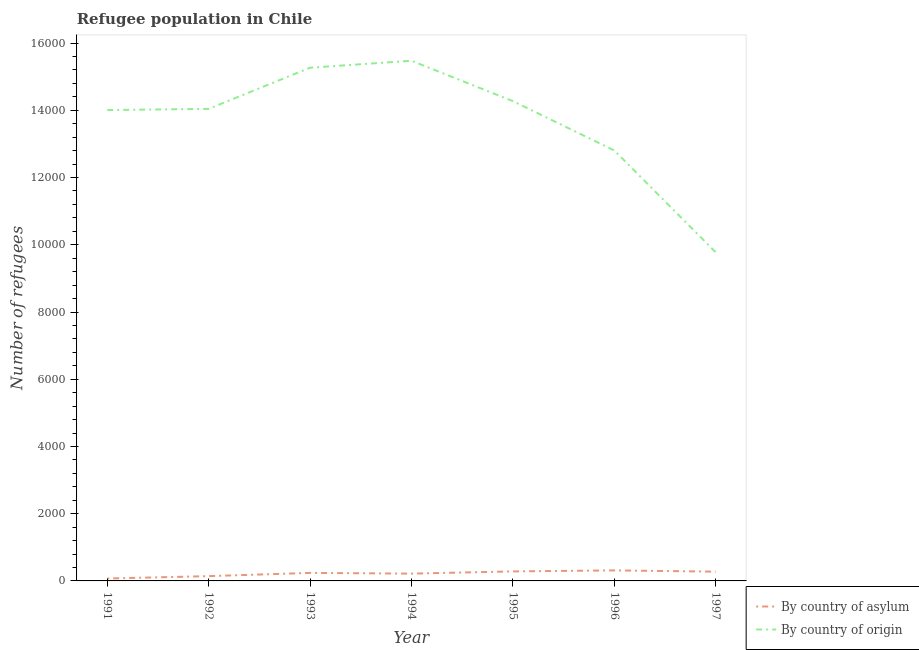What is the number of refugees by country of asylum in 1994?
Provide a succinct answer. 217. Across all years, what is the maximum number of refugees by country of origin?
Your answer should be compact. 1.55e+04. Across all years, what is the minimum number of refugees by country of asylum?
Provide a succinct answer. 72. In which year was the number of refugees by country of asylum maximum?
Your answer should be very brief. 1996. What is the total number of refugees by country of origin in the graph?
Make the answer very short. 9.56e+04. What is the difference between the number of refugees by country of asylum in 1992 and that in 1997?
Your answer should be compact. -134. What is the difference between the number of refugees by country of asylum in 1997 and the number of refugees by country of origin in 1995?
Give a very brief answer. -1.40e+04. What is the average number of refugees by country of asylum per year?
Your answer should be compact. 220.29. In the year 1994, what is the difference between the number of refugees by country of asylum and number of refugees by country of origin?
Provide a succinct answer. -1.53e+04. In how many years, is the number of refugees by country of asylum greater than 11600?
Ensure brevity in your answer.  0. What is the ratio of the number of refugees by country of origin in 1991 to that in 1996?
Provide a short and direct response. 1.09. Is the number of refugees by country of asylum in 1991 less than that in 1993?
Your answer should be very brief. Yes. What is the difference between the highest and the second highest number of refugees by country of origin?
Offer a very short reply. 207. What is the difference between the highest and the lowest number of refugees by country of origin?
Make the answer very short. 5698. Does the number of refugees by country of asylum monotonically increase over the years?
Give a very brief answer. No. How many lines are there?
Keep it short and to the point. 2. How many years are there in the graph?
Keep it short and to the point. 7. What is the difference between two consecutive major ticks on the Y-axis?
Your answer should be compact. 2000. Are the values on the major ticks of Y-axis written in scientific E-notation?
Provide a succinct answer. No. How are the legend labels stacked?
Your answer should be very brief. Vertical. What is the title of the graph?
Offer a terse response. Refugee population in Chile. What is the label or title of the Y-axis?
Ensure brevity in your answer.  Number of refugees. What is the Number of refugees of By country of origin in 1991?
Keep it short and to the point. 1.40e+04. What is the Number of refugees of By country of asylum in 1992?
Offer a very short reply. 142. What is the Number of refugees of By country of origin in 1992?
Keep it short and to the point. 1.40e+04. What is the Number of refugees of By country of asylum in 1993?
Keep it short and to the point. 239. What is the Number of refugees in By country of origin in 1993?
Provide a short and direct response. 1.53e+04. What is the Number of refugees of By country of asylum in 1994?
Ensure brevity in your answer.  217. What is the Number of refugees in By country of origin in 1994?
Your answer should be compact. 1.55e+04. What is the Number of refugees in By country of asylum in 1995?
Keep it short and to the point. 283. What is the Number of refugees in By country of origin in 1995?
Provide a succinct answer. 1.43e+04. What is the Number of refugees in By country of asylum in 1996?
Your answer should be compact. 313. What is the Number of refugees of By country of origin in 1996?
Your response must be concise. 1.28e+04. What is the Number of refugees of By country of asylum in 1997?
Keep it short and to the point. 276. What is the Number of refugees in By country of origin in 1997?
Provide a succinct answer. 9776. Across all years, what is the maximum Number of refugees in By country of asylum?
Offer a terse response. 313. Across all years, what is the maximum Number of refugees of By country of origin?
Your response must be concise. 1.55e+04. Across all years, what is the minimum Number of refugees in By country of asylum?
Ensure brevity in your answer.  72. Across all years, what is the minimum Number of refugees of By country of origin?
Your response must be concise. 9776. What is the total Number of refugees in By country of asylum in the graph?
Give a very brief answer. 1542. What is the total Number of refugees in By country of origin in the graph?
Provide a succinct answer. 9.56e+04. What is the difference between the Number of refugees in By country of asylum in 1991 and that in 1992?
Keep it short and to the point. -70. What is the difference between the Number of refugees in By country of origin in 1991 and that in 1992?
Make the answer very short. -36. What is the difference between the Number of refugees of By country of asylum in 1991 and that in 1993?
Provide a succinct answer. -167. What is the difference between the Number of refugees in By country of origin in 1991 and that in 1993?
Your answer should be very brief. -1260. What is the difference between the Number of refugees of By country of asylum in 1991 and that in 1994?
Ensure brevity in your answer.  -145. What is the difference between the Number of refugees of By country of origin in 1991 and that in 1994?
Your response must be concise. -1467. What is the difference between the Number of refugees of By country of asylum in 1991 and that in 1995?
Make the answer very short. -211. What is the difference between the Number of refugees of By country of origin in 1991 and that in 1995?
Offer a terse response. -266. What is the difference between the Number of refugees of By country of asylum in 1991 and that in 1996?
Provide a short and direct response. -241. What is the difference between the Number of refugees of By country of origin in 1991 and that in 1996?
Provide a succinct answer. 1202. What is the difference between the Number of refugees in By country of asylum in 1991 and that in 1997?
Make the answer very short. -204. What is the difference between the Number of refugees in By country of origin in 1991 and that in 1997?
Give a very brief answer. 4231. What is the difference between the Number of refugees of By country of asylum in 1992 and that in 1993?
Offer a terse response. -97. What is the difference between the Number of refugees of By country of origin in 1992 and that in 1993?
Provide a short and direct response. -1224. What is the difference between the Number of refugees of By country of asylum in 1992 and that in 1994?
Offer a very short reply. -75. What is the difference between the Number of refugees of By country of origin in 1992 and that in 1994?
Your response must be concise. -1431. What is the difference between the Number of refugees of By country of asylum in 1992 and that in 1995?
Offer a very short reply. -141. What is the difference between the Number of refugees in By country of origin in 1992 and that in 1995?
Keep it short and to the point. -230. What is the difference between the Number of refugees of By country of asylum in 1992 and that in 1996?
Your answer should be compact. -171. What is the difference between the Number of refugees of By country of origin in 1992 and that in 1996?
Your answer should be compact. 1238. What is the difference between the Number of refugees in By country of asylum in 1992 and that in 1997?
Give a very brief answer. -134. What is the difference between the Number of refugees in By country of origin in 1992 and that in 1997?
Provide a short and direct response. 4267. What is the difference between the Number of refugees in By country of origin in 1993 and that in 1994?
Your answer should be very brief. -207. What is the difference between the Number of refugees in By country of asylum in 1993 and that in 1995?
Provide a short and direct response. -44. What is the difference between the Number of refugees of By country of origin in 1993 and that in 1995?
Offer a terse response. 994. What is the difference between the Number of refugees of By country of asylum in 1993 and that in 1996?
Your response must be concise. -74. What is the difference between the Number of refugees of By country of origin in 1993 and that in 1996?
Your answer should be very brief. 2462. What is the difference between the Number of refugees of By country of asylum in 1993 and that in 1997?
Offer a terse response. -37. What is the difference between the Number of refugees of By country of origin in 1993 and that in 1997?
Your response must be concise. 5491. What is the difference between the Number of refugees of By country of asylum in 1994 and that in 1995?
Your response must be concise. -66. What is the difference between the Number of refugees of By country of origin in 1994 and that in 1995?
Offer a terse response. 1201. What is the difference between the Number of refugees in By country of asylum in 1994 and that in 1996?
Ensure brevity in your answer.  -96. What is the difference between the Number of refugees in By country of origin in 1994 and that in 1996?
Ensure brevity in your answer.  2669. What is the difference between the Number of refugees of By country of asylum in 1994 and that in 1997?
Provide a succinct answer. -59. What is the difference between the Number of refugees of By country of origin in 1994 and that in 1997?
Offer a very short reply. 5698. What is the difference between the Number of refugees of By country of asylum in 1995 and that in 1996?
Offer a terse response. -30. What is the difference between the Number of refugees in By country of origin in 1995 and that in 1996?
Ensure brevity in your answer.  1468. What is the difference between the Number of refugees of By country of asylum in 1995 and that in 1997?
Make the answer very short. 7. What is the difference between the Number of refugees in By country of origin in 1995 and that in 1997?
Make the answer very short. 4497. What is the difference between the Number of refugees in By country of asylum in 1996 and that in 1997?
Ensure brevity in your answer.  37. What is the difference between the Number of refugees of By country of origin in 1996 and that in 1997?
Your response must be concise. 3029. What is the difference between the Number of refugees of By country of asylum in 1991 and the Number of refugees of By country of origin in 1992?
Your response must be concise. -1.40e+04. What is the difference between the Number of refugees in By country of asylum in 1991 and the Number of refugees in By country of origin in 1993?
Give a very brief answer. -1.52e+04. What is the difference between the Number of refugees in By country of asylum in 1991 and the Number of refugees in By country of origin in 1994?
Provide a short and direct response. -1.54e+04. What is the difference between the Number of refugees in By country of asylum in 1991 and the Number of refugees in By country of origin in 1995?
Offer a terse response. -1.42e+04. What is the difference between the Number of refugees of By country of asylum in 1991 and the Number of refugees of By country of origin in 1996?
Offer a very short reply. -1.27e+04. What is the difference between the Number of refugees in By country of asylum in 1991 and the Number of refugees in By country of origin in 1997?
Offer a terse response. -9704. What is the difference between the Number of refugees of By country of asylum in 1992 and the Number of refugees of By country of origin in 1993?
Provide a short and direct response. -1.51e+04. What is the difference between the Number of refugees of By country of asylum in 1992 and the Number of refugees of By country of origin in 1994?
Offer a very short reply. -1.53e+04. What is the difference between the Number of refugees of By country of asylum in 1992 and the Number of refugees of By country of origin in 1995?
Provide a short and direct response. -1.41e+04. What is the difference between the Number of refugees of By country of asylum in 1992 and the Number of refugees of By country of origin in 1996?
Provide a succinct answer. -1.27e+04. What is the difference between the Number of refugees of By country of asylum in 1992 and the Number of refugees of By country of origin in 1997?
Your response must be concise. -9634. What is the difference between the Number of refugees in By country of asylum in 1993 and the Number of refugees in By country of origin in 1994?
Make the answer very short. -1.52e+04. What is the difference between the Number of refugees of By country of asylum in 1993 and the Number of refugees of By country of origin in 1995?
Provide a short and direct response. -1.40e+04. What is the difference between the Number of refugees of By country of asylum in 1993 and the Number of refugees of By country of origin in 1996?
Your answer should be very brief. -1.26e+04. What is the difference between the Number of refugees in By country of asylum in 1993 and the Number of refugees in By country of origin in 1997?
Keep it short and to the point. -9537. What is the difference between the Number of refugees of By country of asylum in 1994 and the Number of refugees of By country of origin in 1995?
Make the answer very short. -1.41e+04. What is the difference between the Number of refugees in By country of asylum in 1994 and the Number of refugees in By country of origin in 1996?
Keep it short and to the point. -1.26e+04. What is the difference between the Number of refugees in By country of asylum in 1994 and the Number of refugees in By country of origin in 1997?
Offer a very short reply. -9559. What is the difference between the Number of refugees in By country of asylum in 1995 and the Number of refugees in By country of origin in 1996?
Ensure brevity in your answer.  -1.25e+04. What is the difference between the Number of refugees in By country of asylum in 1995 and the Number of refugees in By country of origin in 1997?
Your answer should be compact. -9493. What is the difference between the Number of refugees in By country of asylum in 1996 and the Number of refugees in By country of origin in 1997?
Make the answer very short. -9463. What is the average Number of refugees in By country of asylum per year?
Make the answer very short. 220.29. What is the average Number of refugees in By country of origin per year?
Offer a very short reply. 1.37e+04. In the year 1991, what is the difference between the Number of refugees of By country of asylum and Number of refugees of By country of origin?
Give a very brief answer. -1.39e+04. In the year 1992, what is the difference between the Number of refugees in By country of asylum and Number of refugees in By country of origin?
Provide a succinct answer. -1.39e+04. In the year 1993, what is the difference between the Number of refugees of By country of asylum and Number of refugees of By country of origin?
Ensure brevity in your answer.  -1.50e+04. In the year 1994, what is the difference between the Number of refugees of By country of asylum and Number of refugees of By country of origin?
Offer a terse response. -1.53e+04. In the year 1995, what is the difference between the Number of refugees of By country of asylum and Number of refugees of By country of origin?
Ensure brevity in your answer.  -1.40e+04. In the year 1996, what is the difference between the Number of refugees of By country of asylum and Number of refugees of By country of origin?
Offer a very short reply. -1.25e+04. In the year 1997, what is the difference between the Number of refugees of By country of asylum and Number of refugees of By country of origin?
Give a very brief answer. -9500. What is the ratio of the Number of refugees of By country of asylum in 1991 to that in 1992?
Keep it short and to the point. 0.51. What is the ratio of the Number of refugees of By country of asylum in 1991 to that in 1993?
Keep it short and to the point. 0.3. What is the ratio of the Number of refugees of By country of origin in 1991 to that in 1993?
Offer a terse response. 0.92. What is the ratio of the Number of refugees in By country of asylum in 1991 to that in 1994?
Make the answer very short. 0.33. What is the ratio of the Number of refugees of By country of origin in 1991 to that in 1994?
Ensure brevity in your answer.  0.91. What is the ratio of the Number of refugees of By country of asylum in 1991 to that in 1995?
Offer a terse response. 0.25. What is the ratio of the Number of refugees in By country of origin in 1991 to that in 1995?
Ensure brevity in your answer.  0.98. What is the ratio of the Number of refugees of By country of asylum in 1991 to that in 1996?
Your response must be concise. 0.23. What is the ratio of the Number of refugees in By country of origin in 1991 to that in 1996?
Your answer should be compact. 1.09. What is the ratio of the Number of refugees in By country of asylum in 1991 to that in 1997?
Offer a terse response. 0.26. What is the ratio of the Number of refugees of By country of origin in 1991 to that in 1997?
Keep it short and to the point. 1.43. What is the ratio of the Number of refugees in By country of asylum in 1992 to that in 1993?
Keep it short and to the point. 0.59. What is the ratio of the Number of refugees of By country of origin in 1992 to that in 1993?
Your answer should be compact. 0.92. What is the ratio of the Number of refugees in By country of asylum in 1992 to that in 1994?
Your response must be concise. 0.65. What is the ratio of the Number of refugees in By country of origin in 1992 to that in 1994?
Your response must be concise. 0.91. What is the ratio of the Number of refugees of By country of asylum in 1992 to that in 1995?
Provide a succinct answer. 0.5. What is the ratio of the Number of refugees of By country of origin in 1992 to that in 1995?
Make the answer very short. 0.98. What is the ratio of the Number of refugees in By country of asylum in 1992 to that in 1996?
Keep it short and to the point. 0.45. What is the ratio of the Number of refugees in By country of origin in 1992 to that in 1996?
Give a very brief answer. 1.1. What is the ratio of the Number of refugees of By country of asylum in 1992 to that in 1997?
Give a very brief answer. 0.51. What is the ratio of the Number of refugees of By country of origin in 1992 to that in 1997?
Offer a terse response. 1.44. What is the ratio of the Number of refugees of By country of asylum in 1993 to that in 1994?
Provide a succinct answer. 1.1. What is the ratio of the Number of refugees of By country of origin in 1993 to that in 1994?
Provide a succinct answer. 0.99. What is the ratio of the Number of refugees of By country of asylum in 1993 to that in 1995?
Your answer should be very brief. 0.84. What is the ratio of the Number of refugees in By country of origin in 1993 to that in 1995?
Ensure brevity in your answer.  1.07. What is the ratio of the Number of refugees in By country of asylum in 1993 to that in 1996?
Your answer should be compact. 0.76. What is the ratio of the Number of refugees of By country of origin in 1993 to that in 1996?
Offer a terse response. 1.19. What is the ratio of the Number of refugees in By country of asylum in 1993 to that in 1997?
Provide a succinct answer. 0.87. What is the ratio of the Number of refugees of By country of origin in 1993 to that in 1997?
Keep it short and to the point. 1.56. What is the ratio of the Number of refugees in By country of asylum in 1994 to that in 1995?
Keep it short and to the point. 0.77. What is the ratio of the Number of refugees in By country of origin in 1994 to that in 1995?
Offer a terse response. 1.08. What is the ratio of the Number of refugees in By country of asylum in 1994 to that in 1996?
Your answer should be very brief. 0.69. What is the ratio of the Number of refugees of By country of origin in 1994 to that in 1996?
Ensure brevity in your answer.  1.21. What is the ratio of the Number of refugees in By country of asylum in 1994 to that in 1997?
Make the answer very short. 0.79. What is the ratio of the Number of refugees in By country of origin in 1994 to that in 1997?
Provide a succinct answer. 1.58. What is the ratio of the Number of refugees of By country of asylum in 1995 to that in 1996?
Make the answer very short. 0.9. What is the ratio of the Number of refugees in By country of origin in 1995 to that in 1996?
Provide a succinct answer. 1.11. What is the ratio of the Number of refugees in By country of asylum in 1995 to that in 1997?
Your response must be concise. 1.03. What is the ratio of the Number of refugees of By country of origin in 1995 to that in 1997?
Your answer should be very brief. 1.46. What is the ratio of the Number of refugees of By country of asylum in 1996 to that in 1997?
Provide a short and direct response. 1.13. What is the ratio of the Number of refugees of By country of origin in 1996 to that in 1997?
Provide a short and direct response. 1.31. What is the difference between the highest and the second highest Number of refugees of By country of asylum?
Your answer should be compact. 30. What is the difference between the highest and the second highest Number of refugees in By country of origin?
Provide a short and direct response. 207. What is the difference between the highest and the lowest Number of refugees of By country of asylum?
Your answer should be compact. 241. What is the difference between the highest and the lowest Number of refugees of By country of origin?
Your response must be concise. 5698. 